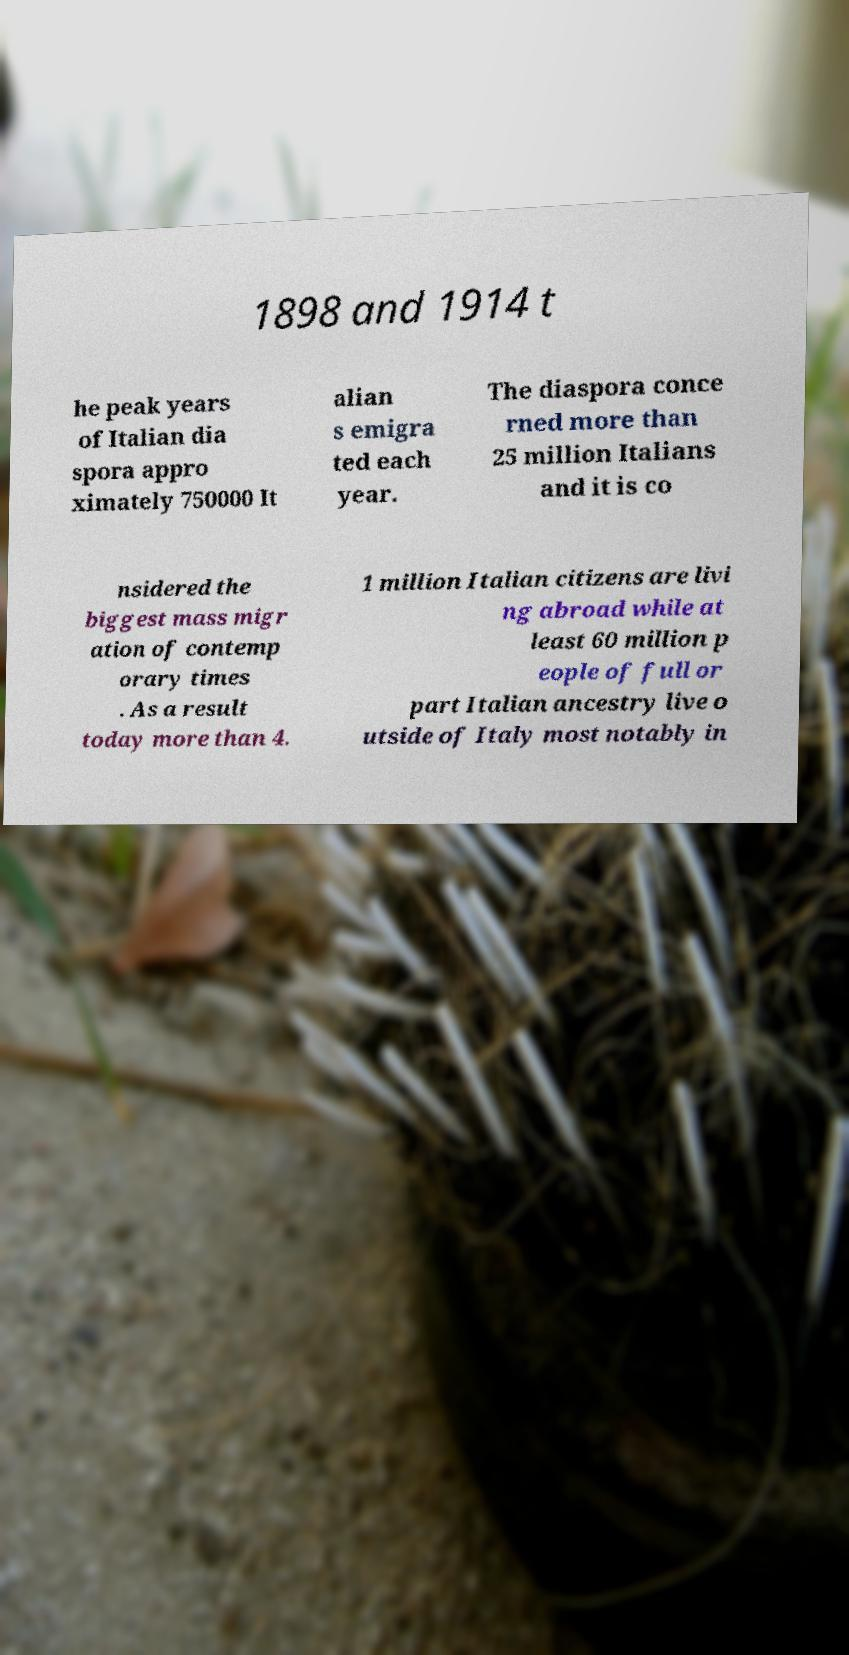Please identify and transcribe the text found in this image. 1898 and 1914 t he peak years of Italian dia spora appro ximately 750000 It alian s emigra ted each year. The diaspora conce rned more than 25 million Italians and it is co nsidered the biggest mass migr ation of contemp orary times . As a result today more than 4. 1 million Italian citizens are livi ng abroad while at least 60 million p eople of full or part Italian ancestry live o utside of Italy most notably in 